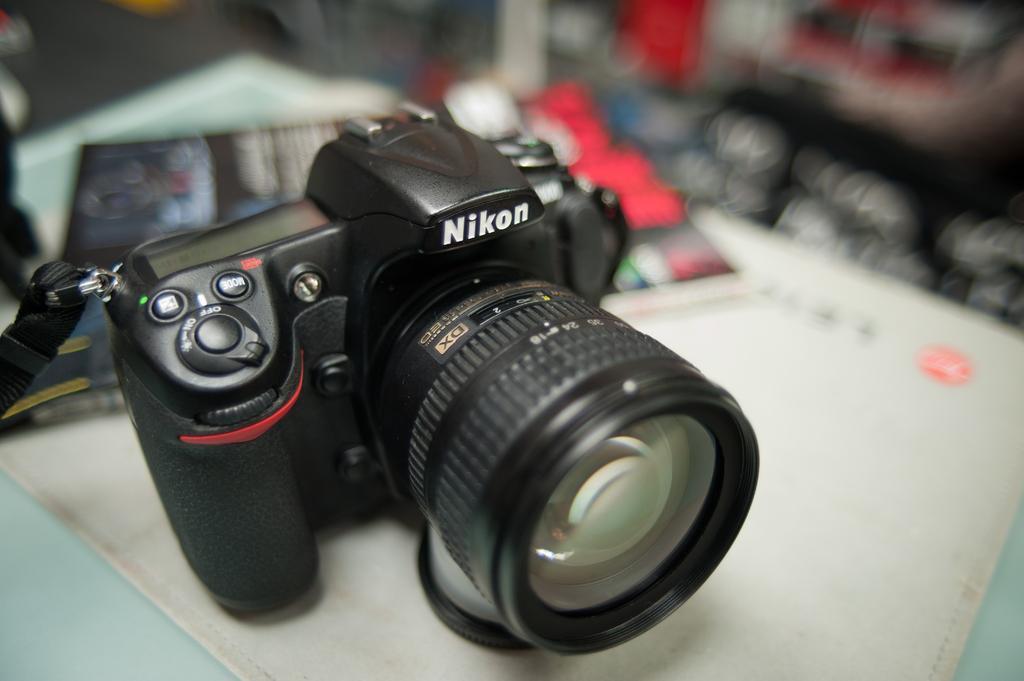How would you summarize this image in a sentence or two? In this picture we can see a camera and books on a platform and in the background it is blurry. 